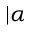<formula> <loc_0><loc_0><loc_500><loc_500>| \alpha \ r r a n g l e</formula> 